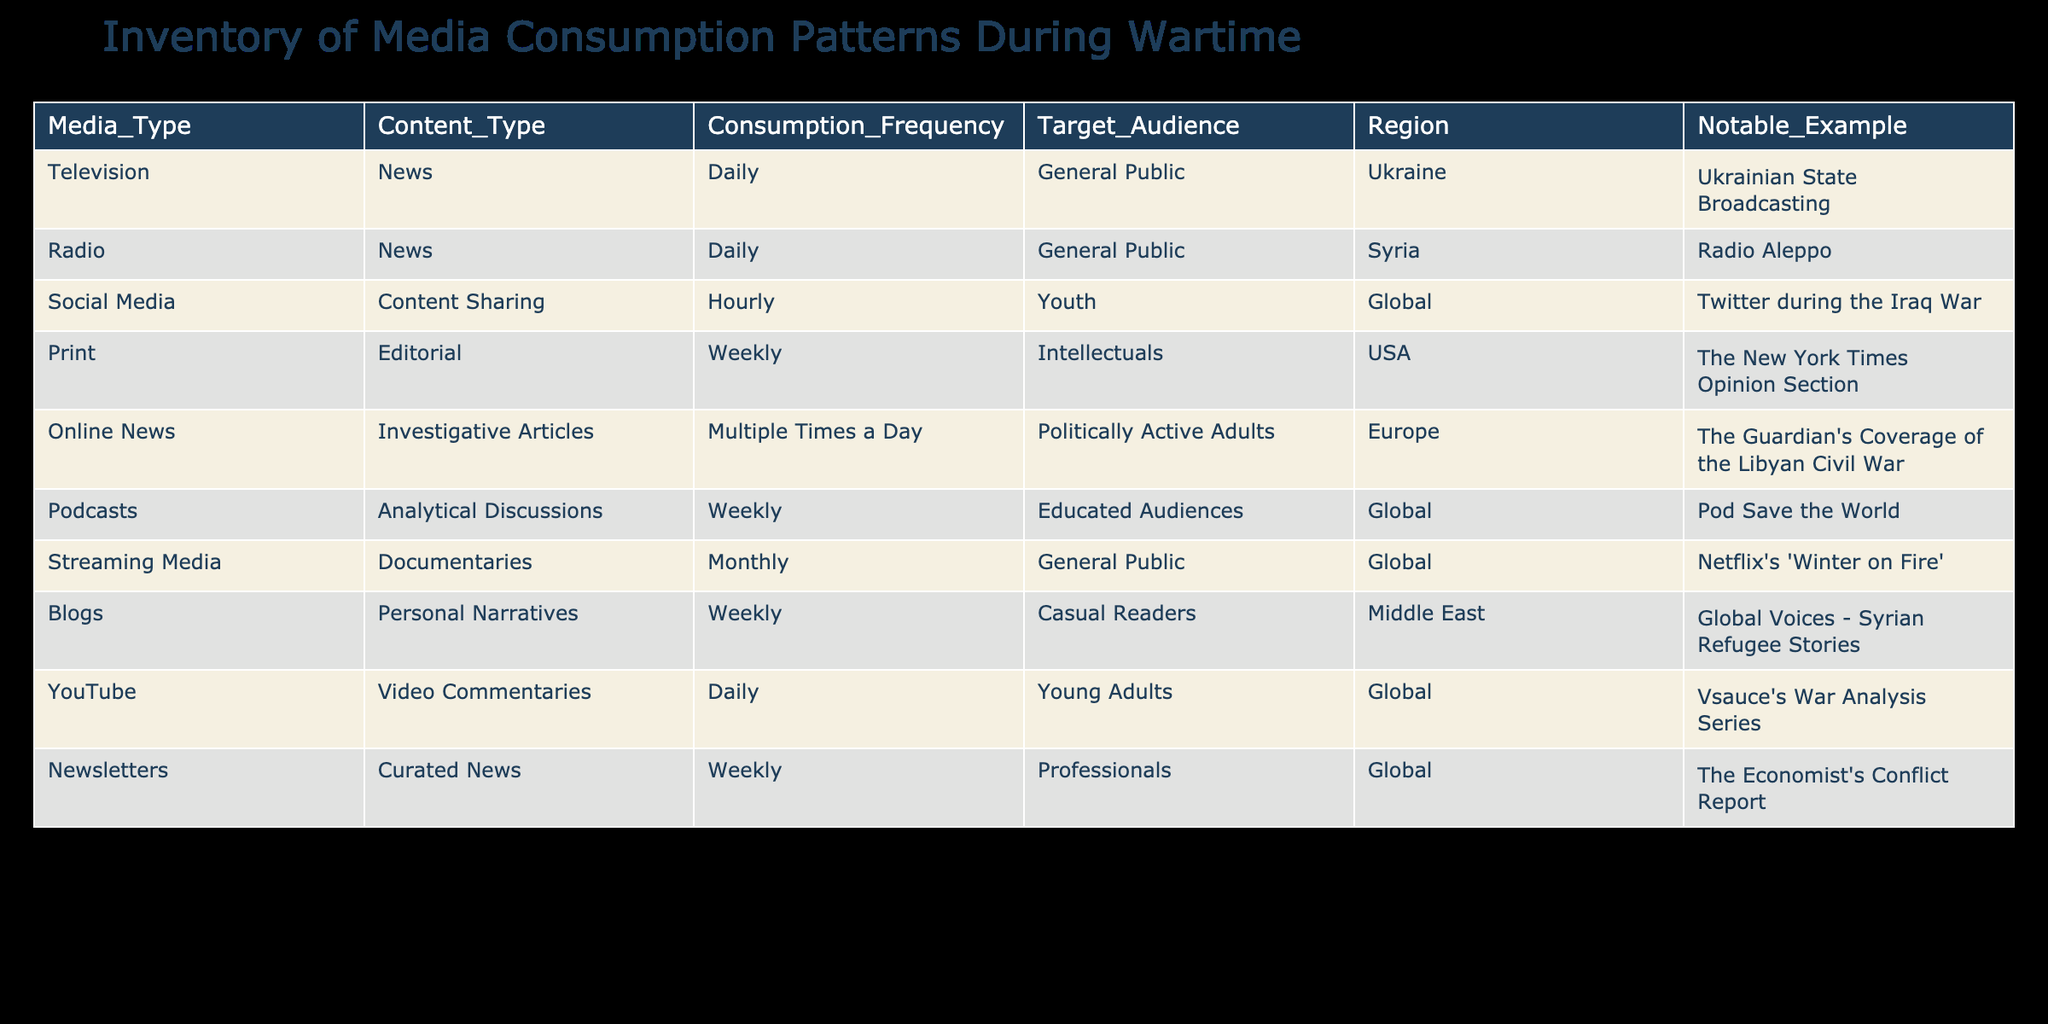What is the target audience for online news? The table indicates that the target audience for online news is "Politically Active Adults." This information is directly found in the "Target_Audience" column corresponding to "Online News."
Answer: Politically Active Adults How often is social media content consumed during wartime? According to the table, social media content is consumed "Hourly," as mentioned in the "Consumption_Frequency" column for the "Social Media" row.
Answer: Hourly Which media type has "Weekly" as the consumption frequency? There are multiple entries with "Weekly" as the consumption frequency in the table, namely Print, Podcasts, Blogs, and Newsletters. Each of them can be identified under the "Consumption_Frequency" column.
Answer: Print, Podcasts, Blogs, Newsletters Is YouTube used primarily by young adults for media consumption during wartime? Yes, the table states that the target audience for YouTube is "Young Adults," making this statement true based on the data provided in the "Target_Audience" column.
Answer: Yes Which media type has the general public as its target audience and is consumed daily? The table shows two media types with "General Public" as the target audience and "Daily" consumption frequency: Television and Radio. These can be directly identified from the "Target_Audience" and "Consumption_Frequency" columns.
Answer: Television, Radio What is the average frequency of print media consumption compared to online news? The frequency for print media is weekly (1 time a week), while online news has a frequency of multiple times a day (approximately 3 times). To find the average, convert print to a frequency value (1) and online news to a rough estimate (3). The average calculation is (1 + 3) / 2 = 2.
Answer: 2 Are documentaries consumed more frequently than analytical discussions according to the table? The table states that documentaries are consumed monthly, while analytical discussions (Podcasts) are consumed weekly. Since monthly is less frequent than weekly, the assertion is false.
Answer: No What notable example is associated with the print media type? The table lists "The New York Times Opinion Section" as the notable example for print media in the "Notable_Example" column. This can be directly retrieved from that specific row.
Answer: The New York Times Opinion Section Which region has the most diverse media types targeted towards the general public? The table specifies that both Ukraine and Syria provide media types targeted at the general public, represented by television news and radio news respectively. To assess diversity, we observe that these two examples comprise different media ads in different regions. Therefore, while both share the same target audience, they originate from distinct regional contexts.
Answer: Ukraine, Syria 